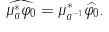Convert formula to latex. <formula><loc_0><loc_0><loc_500><loc_500>\widehat { \mu _ { a } ^ { * } \varphi _ { 0 } } = \mu _ { a ^ { - 1 } } ^ { * } \widehat { \varphi _ { 0 } } . \\</formula> 